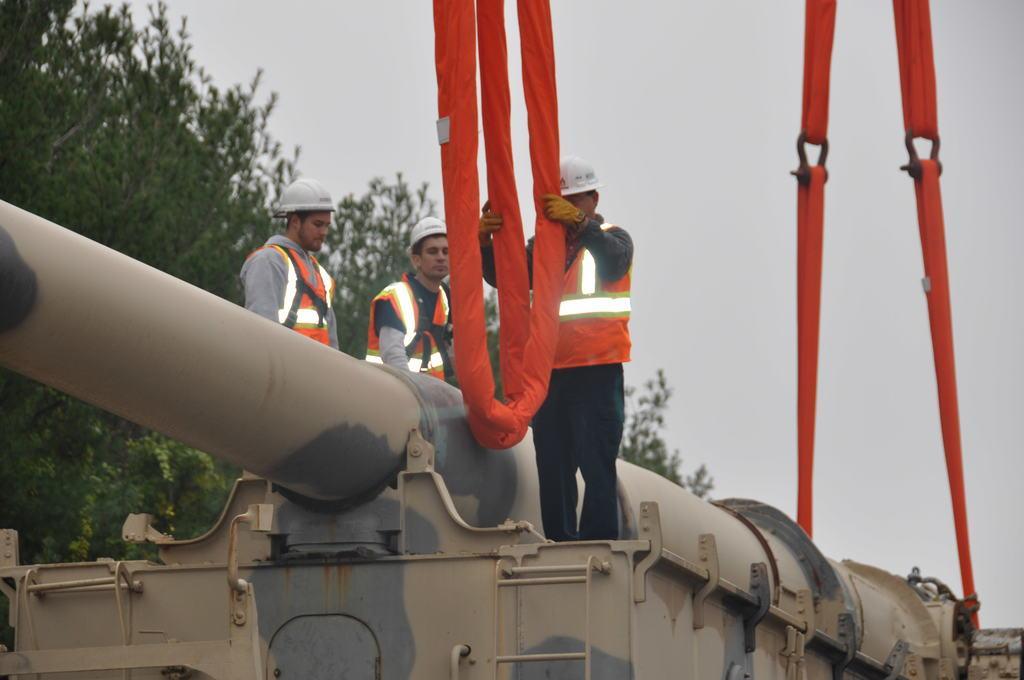How would you summarize this image in a sentence or two? In this image, I can see three people standing. It looks like a military vehicle. I think these are the ropes. I can see the trees. This is the sky. 